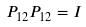Convert formula to latex. <formula><loc_0><loc_0><loc_500><loc_500>P _ { 1 2 } P _ { 1 2 } = I</formula> 